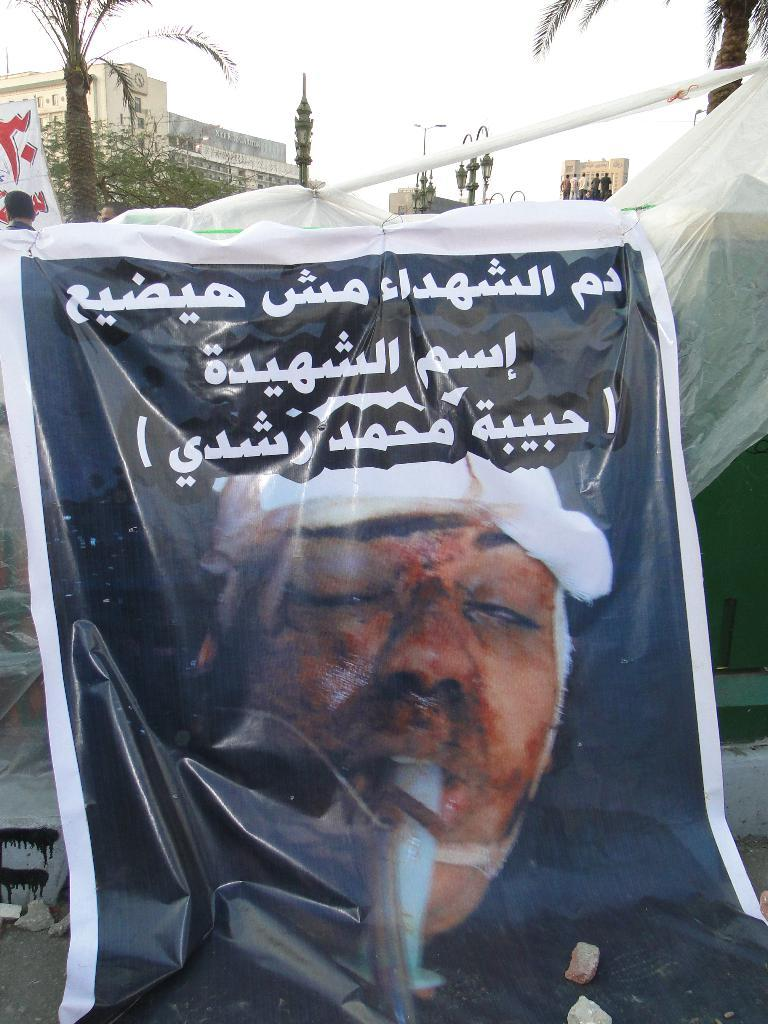What is featured on the banner in the image? The banner in the image has text and an image of a person. What can be seen in the background of the image? In the background of the image, there is a cover, trees, light poles, buildings, people, and the sky. Can you describe the setting of the image? The image is set in an outdoor area with a banner, cover, trees, light poles, buildings, people, and the sky visible in the background. What type of clock is hanging from the light pole in the image? There is no clock visible in the image; only light poles, trees, buildings, people, and the sky are present in the background. 